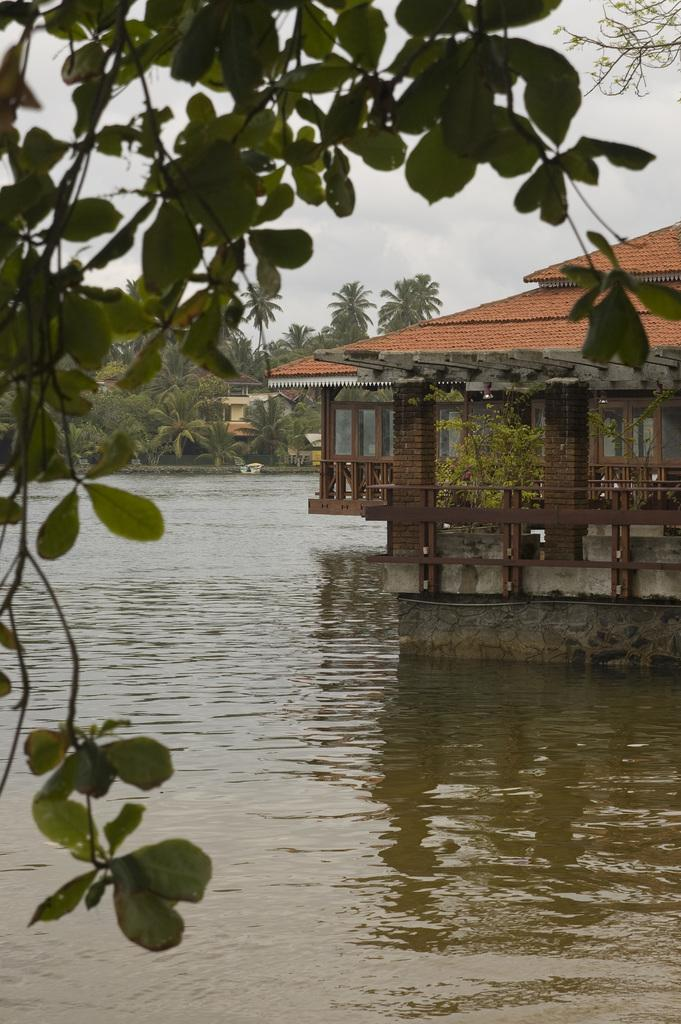What type of vegetation is on the left side of the image? There is a tree on the left side of the image. What can be seen in the middle of the image? There is water in the middle of the image. What type of structure is on the right side of the image? There is a house on the right side of the image. What type of alley can be seen behind the house in the image? There is no alley visible in the image; it only shows a tree, water, and a house. How many bedrooms are in the house in the image? The number of bedrooms in the house cannot be determined from the image, as it only shows the exterior of the house. 